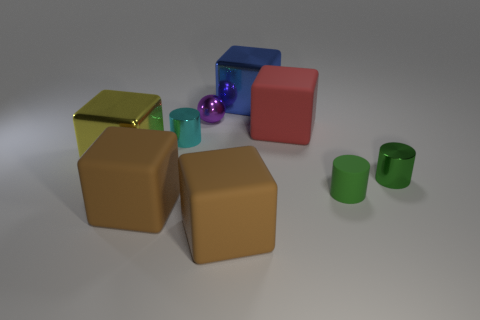Subtract all yellow metal blocks. How many blocks are left? 4 Subtract all blue cubes. How many cubes are left? 4 Subtract all purple cubes. Subtract all red cylinders. How many cubes are left? 5 Add 1 large matte cubes. How many objects exist? 10 Subtract all cubes. How many objects are left? 4 Add 8 small matte things. How many small matte things are left? 9 Add 4 big objects. How many big objects exist? 9 Subtract 0 cyan balls. How many objects are left? 9 Subtract all purple matte balls. Subtract all large cubes. How many objects are left? 4 